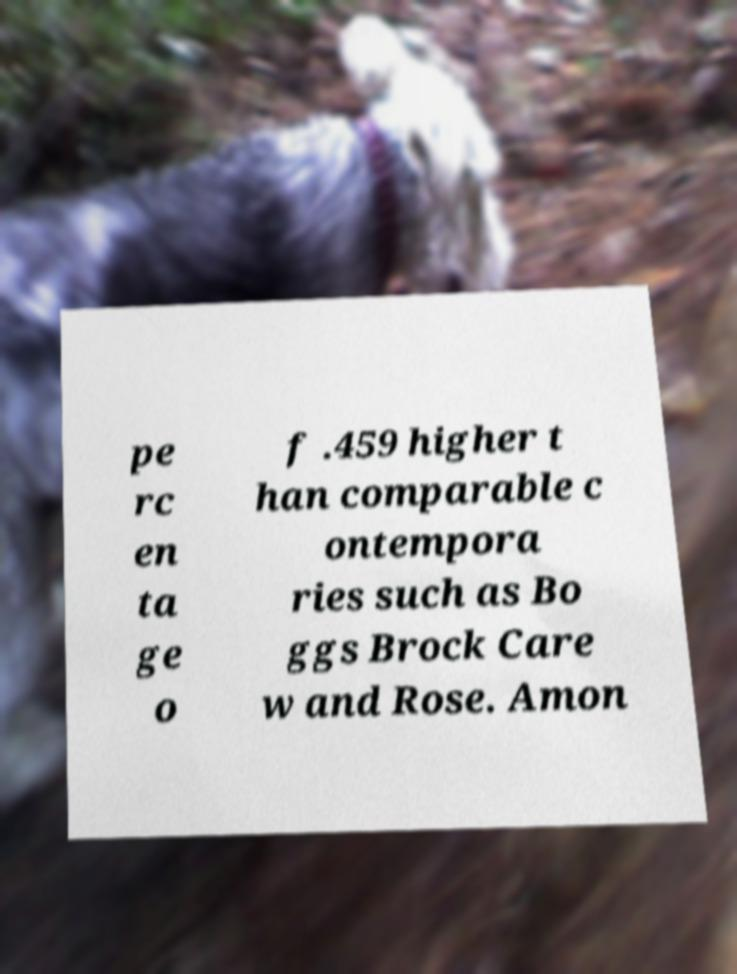For documentation purposes, I need the text within this image transcribed. Could you provide that? pe rc en ta ge o f .459 higher t han comparable c ontempora ries such as Bo ggs Brock Care w and Rose. Amon 